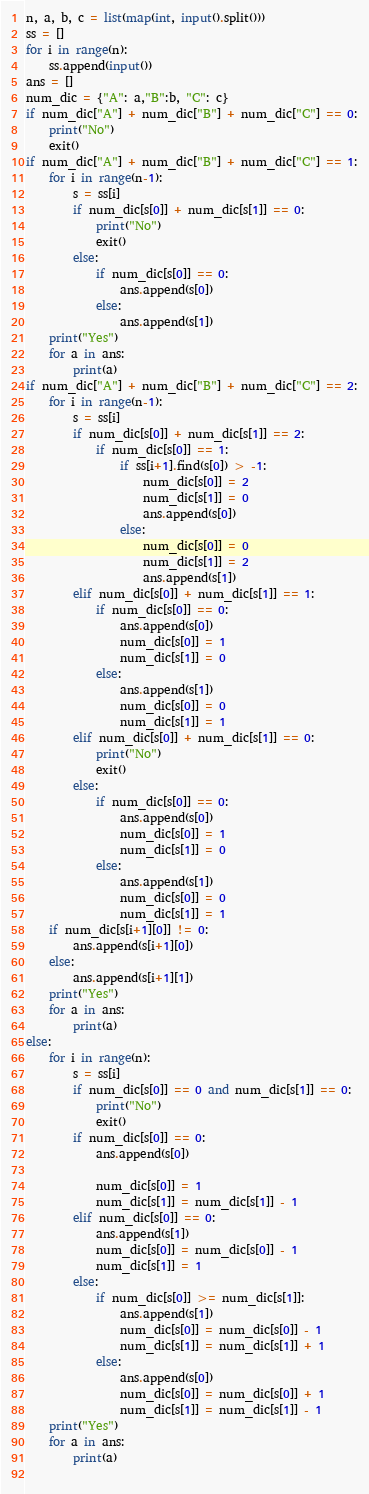<code> <loc_0><loc_0><loc_500><loc_500><_Python_>n, a, b, c = list(map(int, input().split()))
ss = []
for i in range(n):
    ss.append(input())
ans = []
num_dic = {"A": a,"B":b, "C": c}
if num_dic["A"] + num_dic["B"] + num_dic["C"] == 0:
    print("No")
    exit()
if num_dic["A"] + num_dic["B"] + num_dic["C"] == 1:
    for i in range(n-1):
        s = ss[i]
        if num_dic[s[0]] + num_dic[s[1]] == 0:
            print("No")
            exit()
        else:
            if num_dic[s[0]] == 0:
                ans.append(s[0])
            else:
                ans.append(s[1])
    print("Yes")
    for a in ans:
        print(a)
if num_dic["A"] + num_dic["B"] + num_dic["C"] == 2:
    for i in range(n-1):
        s = ss[i]
        if num_dic[s[0]] + num_dic[s[1]] == 2:
            if num_dic[s[0]] == 1:
                if ss[i+1].find(s[0]) > -1:
                    num_dic[s[0]] = 2
                    num_dic[s[1]] = 0
                    ans.append(s[0])
                else:
                    num_dic[s[0]] = 0
                    num_dic[s[1]] = 2
                    ans.append(s[1])
        elif num_dic[s[0]] + num_dic[s[1]] == 1:
            if num_dic[s[0]] == 0:
                ans.append(s[0])
                num_dic[s[0]] = 1
                num_dic[s[1]] = 0
            else:
                ans.append(s[1])
                num_dic[s[0]] = 0
                num_dic[s[1]] = 1
        elif num_dic[s[0]] + num_dic[s[1]] == 0:
            print("No")
            exit()
        else:
            if num_dic[s[0]] == 0:
                ans.append(s[0])
                num_dic[s[0]] = 1
                num_dic[s[1]] = 0
            else:
                ans.append(s[1])
                num_dic[s[0]] = 0
                num_dic[s[1]] = 1
    if num_dic[s[i+1][0]] != 0:
        ans.append(s[i+1][0])
    else:
        ans.append(s[i+1][1])
    print("Yes")
    for a in ans:
        print(a)
else:
    for i in range(n):
        s = ss[i]
        if num_dic[s[0]] == 0 and num_dic[s[1]] == 0:
            print("No")
            exit()
        if num_dic[s[0]] == 0:
            ans.append(s[0])
            
            num_dic[s[0]] = 1
            num_dic[s[1]] = num_dic[s[1]] - 1
        elif num_dic[s[0]] == 0:
            ans.append(s[1])
            num_dic[s[0]] = num_dic[s[0]] - 1
            num_dic[s[1]] = 1
        else:
            if num_dic[s[0]] >= num_dic[s[1]]:
                ans.append(s[1])
                num_dic[s[0]] = num_dic[s[0]] - 1
                num_dic[s[1]] = num_dic[s[1]] + 1
            else:
                ans.append(s[0])
                num_dic[s[0]] = num_dic[s[0]] + 1
                num_dic[s[1]] = num_dic[s[1]] - 1
    print("Yes")
    for a in ans:
        print(a)
    
</code> 